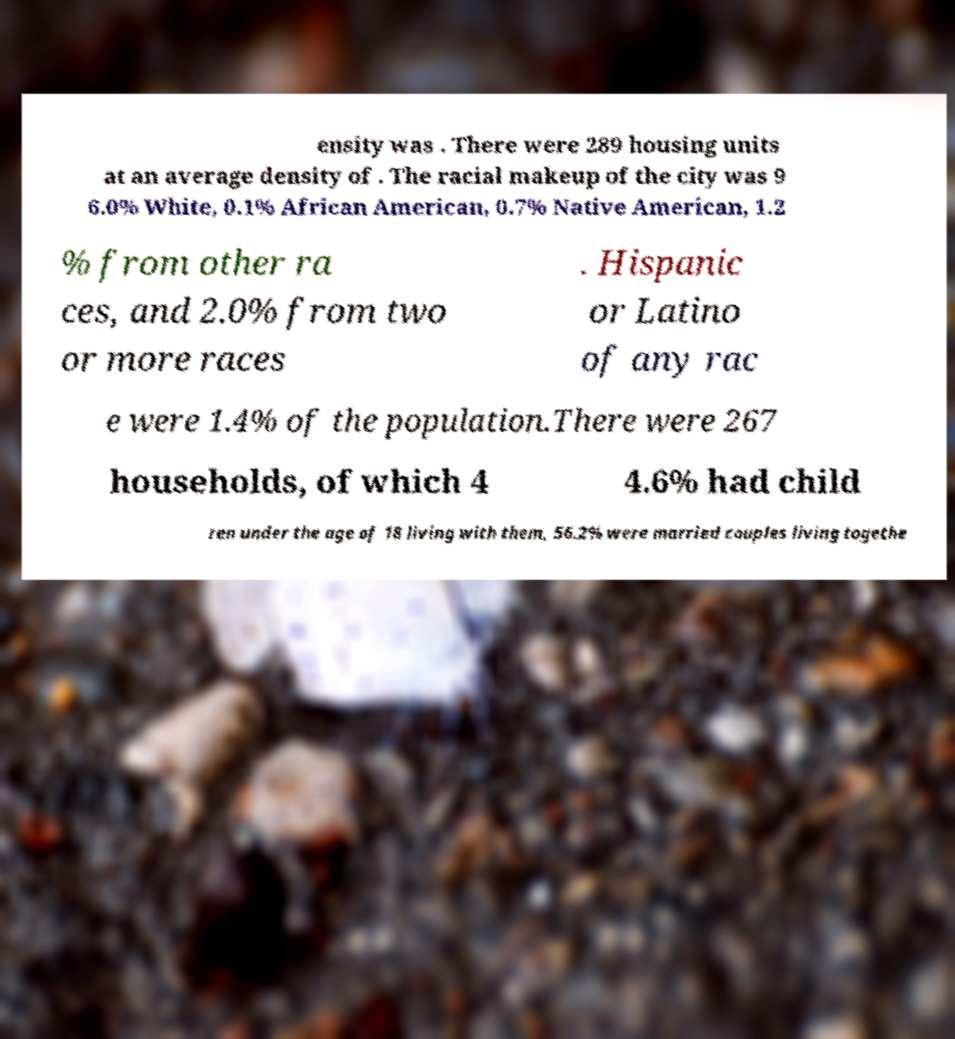Can you accurately transcribe the text from the provided image for me? ensity was . There were 289 housing units at an average density of . The racial makeup of the city was 9 6.0% White, 0.1% African American, 0.7% Native American, 1.2 % from other ra ces, and 2.0% from two or more races . Hispanic or Latino of any rac e were 1.4% of the population.There were 267 households, of which 4 4.6% had child ren under the age of 18 living with them, 56.2% were married couples living togethe 